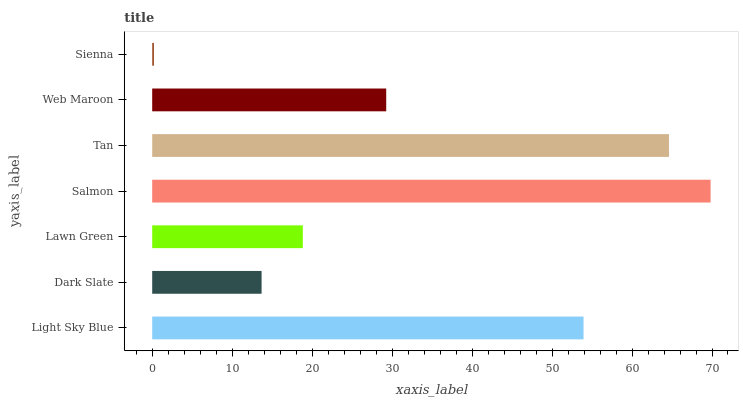Is Sienna the minimum?
Answer yes or no. Yes. Is Salmon the maximum?
Answer yes or no. Yes. Is Dark Slate the minimum?
Answer yes or no. No. Is Dark Slate the maximum?
Answer yes or no. No. Is Light Sky Blue greater than Dark Slate?
Answer yes or no. Yes. Is Dark Slate less than Light Sky Blue?
Answer yes or no. Yes. Is Dark Slate greater than Light Sky Blue?
Answer yes or no. No. Is Light Sky Blue less than Dark Slate?
Answer yes or no. No. Is Web Maroon the high median?
Answer yes or no. Yes. Is Web Maroon the low median?
Answer yes or no. Yes. Is Light Sky Blue the high median?
Answer yes or no. No. Is Lawn Green the low median?
Answer yes or no. No. 